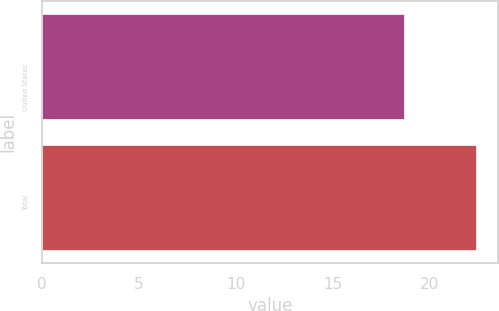<chart> <loc_0><loc_0><loc_500><loc_500><bar_chart><fcel>United States<fcel>Total<nl><fcel>18.7<fcel>22.4<nl></chart> 